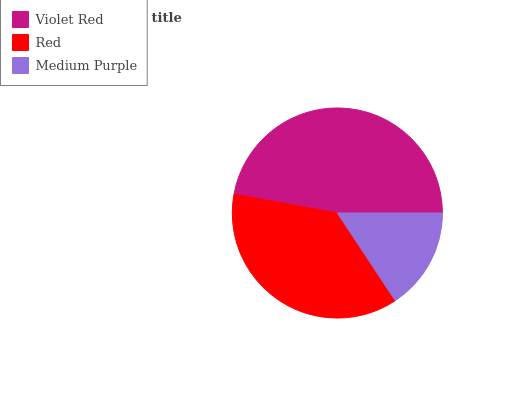Is Medium Purple the minimum?
Answer yes or no. Yes. Is Violet Red the maximum?
Answer yes or no. Yes. Is Red the minimum?
Answer yes or no. No. Is Red the maximum?
Answer yes or no. No. Is Violet Red greater than Red?
Answer yes or no. Yes. Is Red less than Violet Red?
Answer yes or no. Yes. Is Red greater than Violet Red?
Answer yes or no. No. Is Violet Red less than Red?
Answer yes or no. No. Is Red the high median?
Answer yes or no. Yes. Is Red the low median?
Answer yes or no. Yes. Is Violet Red the high median?
Answer yes or no. No. Is Violet Red the low median?
Answer yes or no. No. 